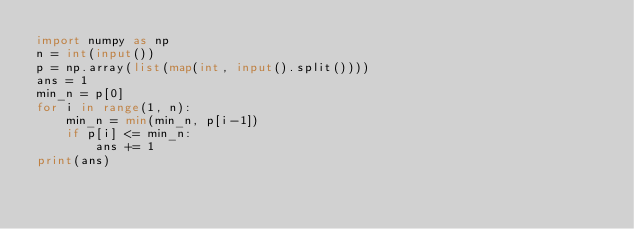Convert code to text. <code><loc_0><loc_0><loc_500><loc_500><_Python_>import numpy as np
n = int(input())
p = np.array(list(map(int, input().split())))
ans = 1
min_n = p[0]
for i in range(1, n):
    min_n = min(min_n, p[i-1])
    if p[i] <= min_n:
        ans += 1
print(ans)
</code> 